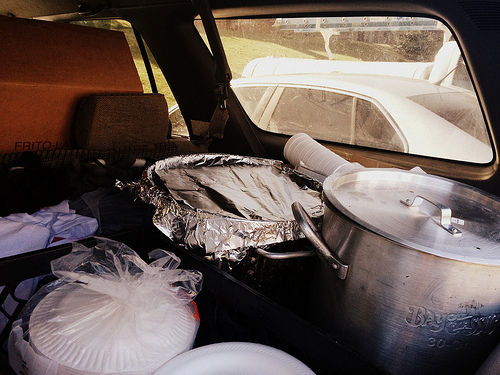<image>
Is the lid to the left of the pot? No. The lid is not to the left of the pot. From this viewpoint, they have a different horizontal relationship. 